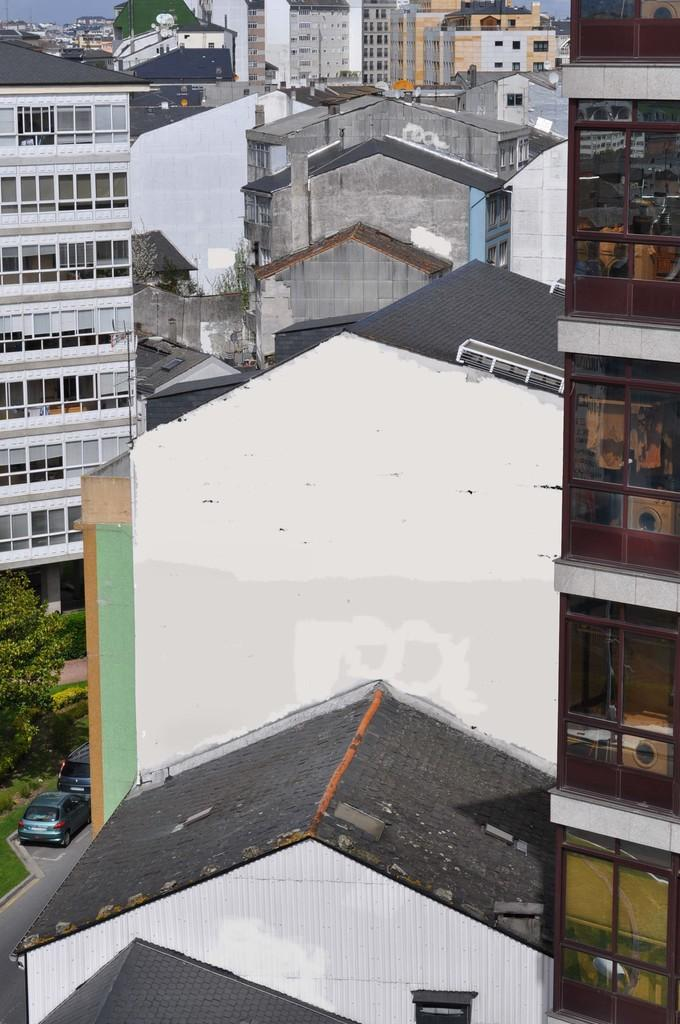What type of structures can be seen in the image? There are buildings in the image. What architectural elements are present in the image? There are walls, windows, and a pillar in the image. What can be seen in the sky in the image? The sky is visible at the top of the image. What type of vegetation is on the left side of the image? There is a tree, plants, and grass on the left side of the image. What is present on the left side of the image that might be used for transportation? There are vehicles on the left side of the image. What surface might be used for driving or walking on the left side of the image? There is a road on the left side of the image. What type of square is present on the right side of the image? There is no square present on the right side of the image. Does the existence of the buildings in the image prove the existence of life on other planets? The presence of buildings in the image does not provide any information about the existence of life on other planets. 